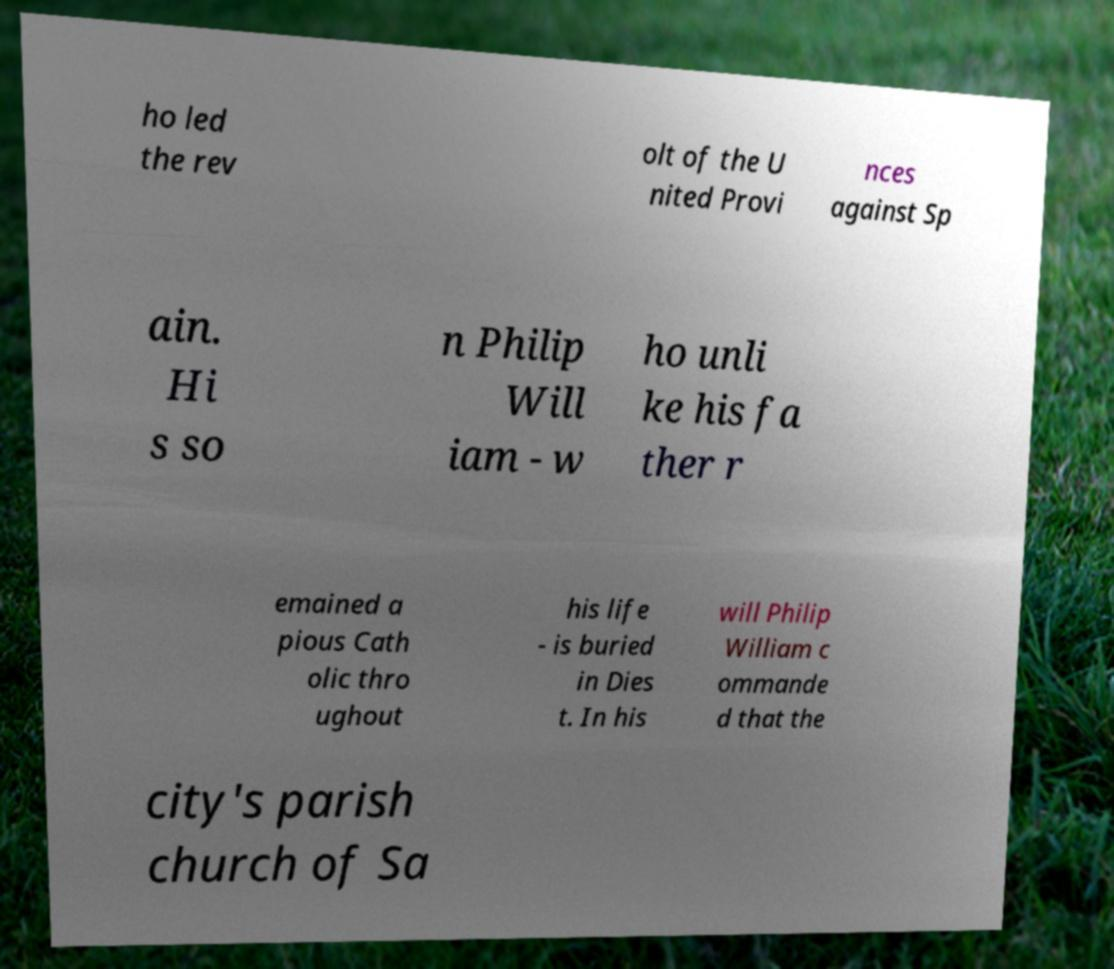Could you assist in decoding the text presented in this image and type it out clearly? ho led the rev olt of the U nited Provi nces against Sp ain. Hi s so n Philip Will iam - w ho unli ke his fa ther r emained a pious Cath olic thro ughout his life - is buried in Dies t. In his will Philip William c ommande d that the city's parish church of Sa 